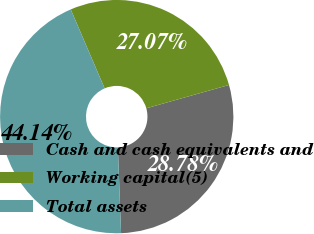Convert chart. <chart><loc_0><loc_0><loc_500><loc_500><pie_chart><fcel>Cash and cash equivalents and<fcel>Working capital(5)<fcel>Total assets<nl><fcel>28.78%<fcel>27.07%<fcel>44.14%<nl></chart> 